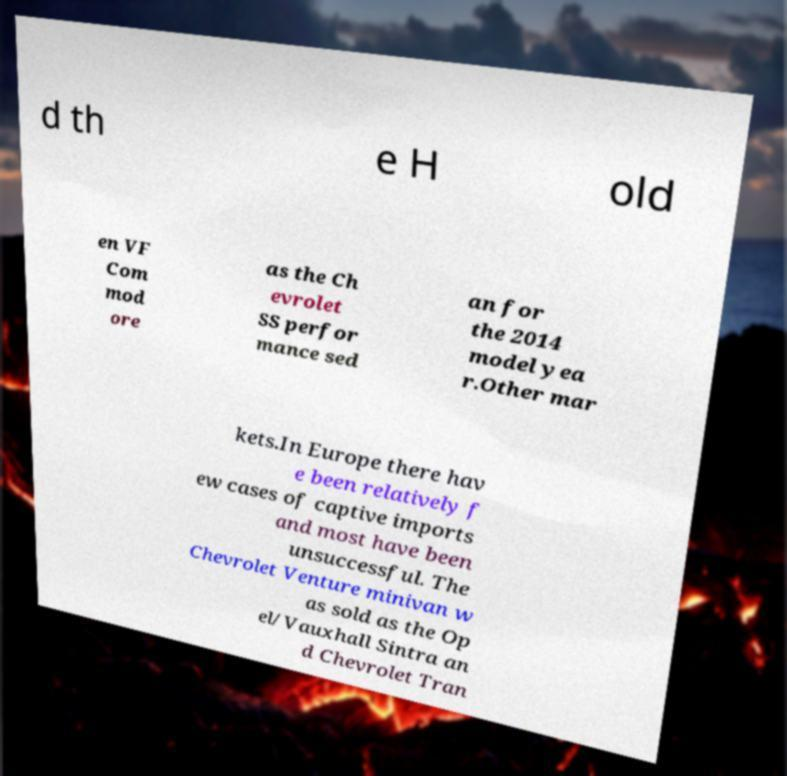Please identify and transcribe the text found in this image. d th e H old en VF Com mod ore as the Ch evrolet SS perfor mance sed an for the 2014 model yea r.Other mar kets.In Europe there hav e been relatively f ew cases of captive imports and most have been unsuccessful. The Chevrolet Venture minivan w as sold as the Op el/Vauxhall Sintra an d Chevrolet Tran 